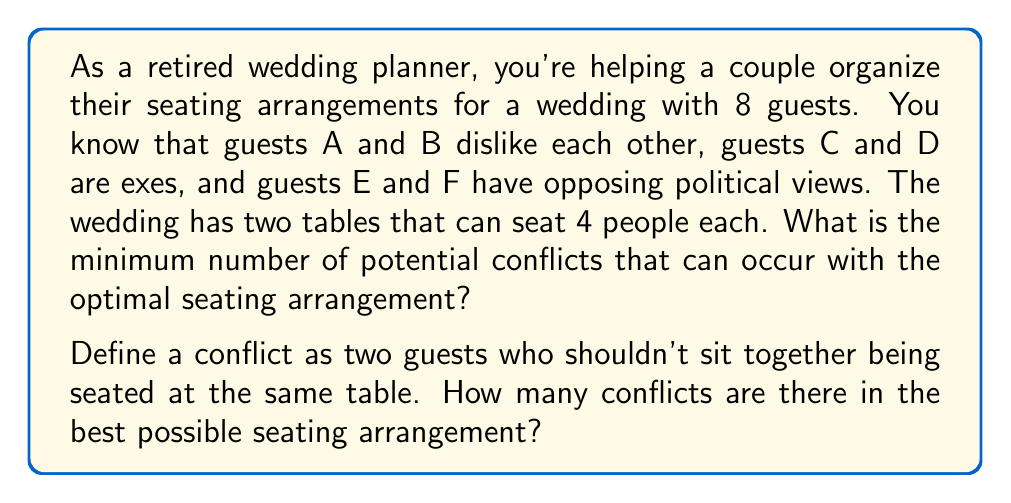What is the answer to this math problem? To solve this problem, we need to use concepts from graph theory and combinatorics. Let's approach this step-by-step:

1) First, we can represent the conflicts as an undirected graph, where each guest is a node and each conflict is an edge connecting two nodes.

2) We have three conflicts:
   A-B, C-D, E-F

3) Our goal is to divide these 8 guests into two groups of 4, minimizing the number of conflicts within each group.

4) The optimal solution will be to separate each conflicting pair into different tables. However, with 3 conflicting pairs and only 2 tables, we know at least one conflict must occur.

5) To find the best arrangement, we can use the concept of graph bipartitioning. We want to divide the graph into two equal parts while minimizing the number of edges (conflicts) that cross between the parts.

6) Let's consider the possible arrangements:
   Table 1: A, C, E, G
   Table 2: B, D, F, H

   This arrangement separates all conflicting pairs except for one.

7) We can prove this is optimal:
   - We can't separate all three conflicting pairs with only two tables.
   - Any arrangement that keeps two conflicting pairs at the same table would be worse than this arrangement.

8) Therefore, the minimum number of conflicts in the best possible arrangement is 1.

This solution demonstrates the application of graph theory to a real-world problem, showcasing how mathematical concepts can be used to optimize seating arrangements and minimize potential social conflicts at events.
Answer: The minimum number of conflicts in the optimal seating arrangement is 1. 